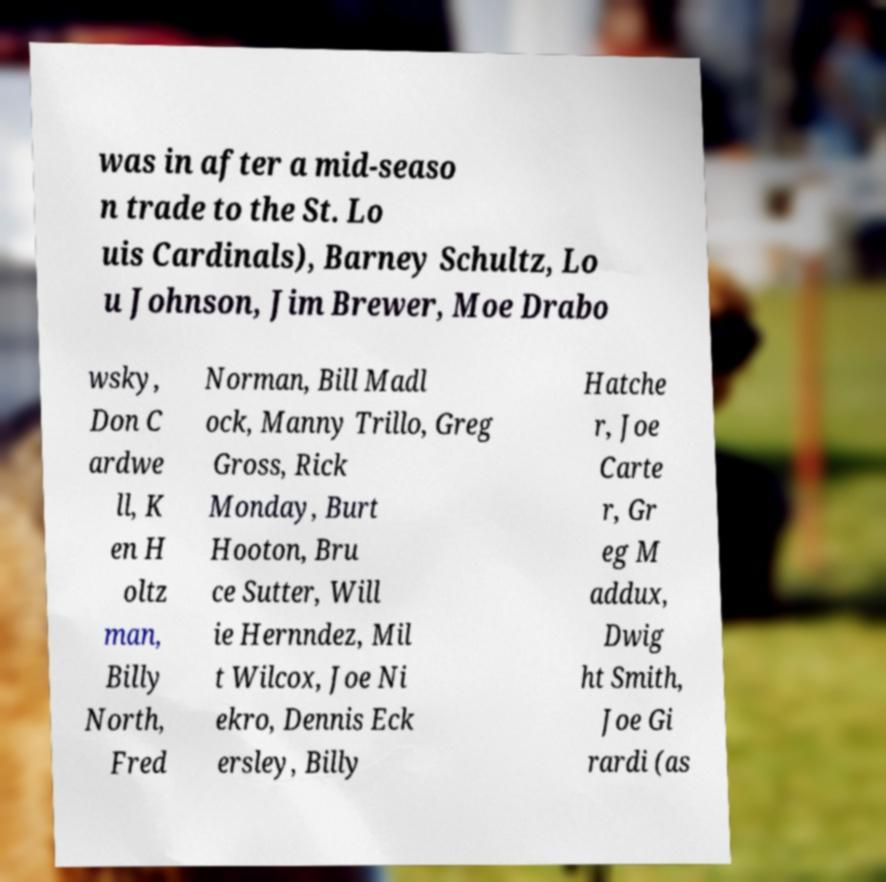What messages or text are displayed in this image? I need them in a readable, typed format. was in after a mid-seaso n trade to the St. Lo uis Cardinals), Barney Schultz, Lo u Johnson, Jim Brewer, Moe Drabo wsky, Don C ardwe ll, K en H oltz man, Billy North, Fred Norman, Bill Madl ock, Manny Trillo, Greg Gross, Rick Monday, Burt Hooton, Bru ce Sutter, Will ie Hernndez, Mil t Wilcox, Joe Ni ekro, Dennis Eck ersley, Billy Hatche r, Joe Carte r, Gr eg M addux, Dwig ht Smith, Joe Gi rardi (as 